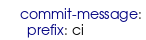<code> <loc_0><loc_0><loc_500><loc_500><_YAML_>    commit-message:
      prefix: ci
</code> 